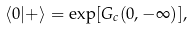Convert formula to latex. <formula><loc_0><loc_0><loc_500><loc_500>\langle 0 | + \rangle = \exp [ G _ { c } ( 0 , - \infty ) ] ,</formula> 